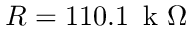<formula> <loc_0><loc_0><loc_500><loc_500>R = 1 1 0 . 1 \, k \Omega</formula> 